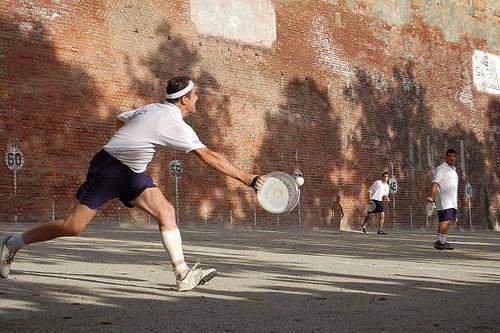How many people are playing ball?
Give a very brief answer. 3. How many people can you see?
Give a very brief answer. 2. How many horses have white in their coat?
Give a very brief answer. 0. 